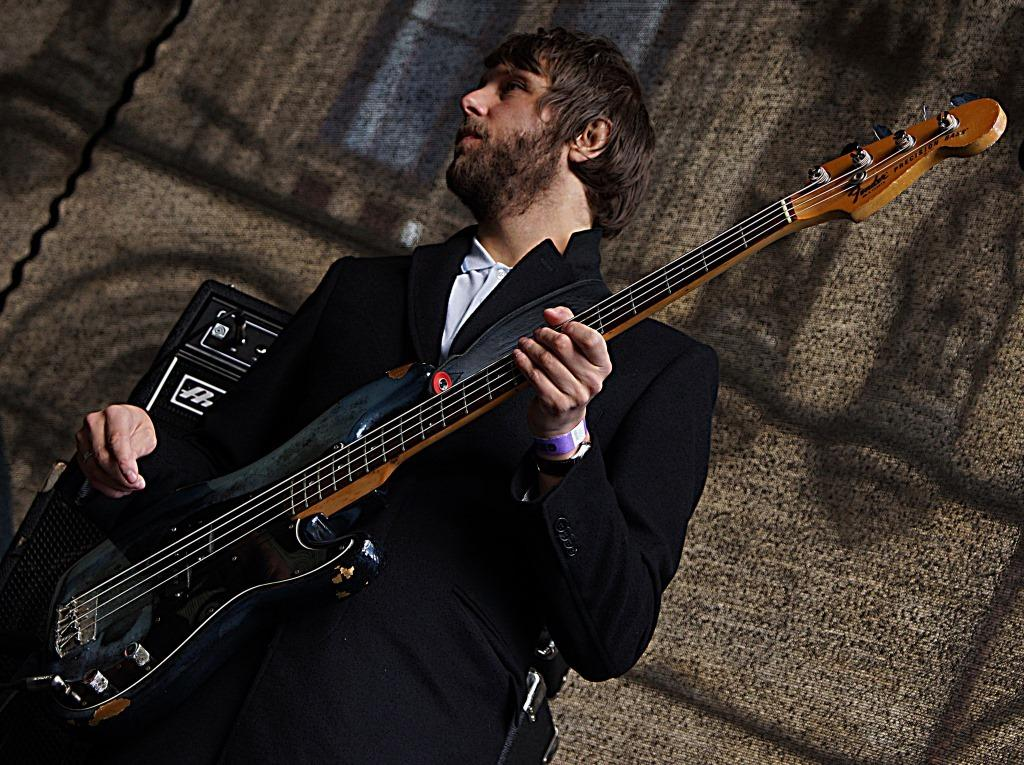Who is the main subject in the image? There is a man in the image. What is the man doing in the image? The man is playing the guitar. What is the man wearing in the image? The man is wearing a suit. What is the man's posture in the image? The man is standing in the image. Can you see any tubs or seashores in the image? No, there are no tubs or seashores present in the image. What type of paper is the man holding while playing the guitar? The man is not holding any paper in the image; he is playing the guitar with his hands. 